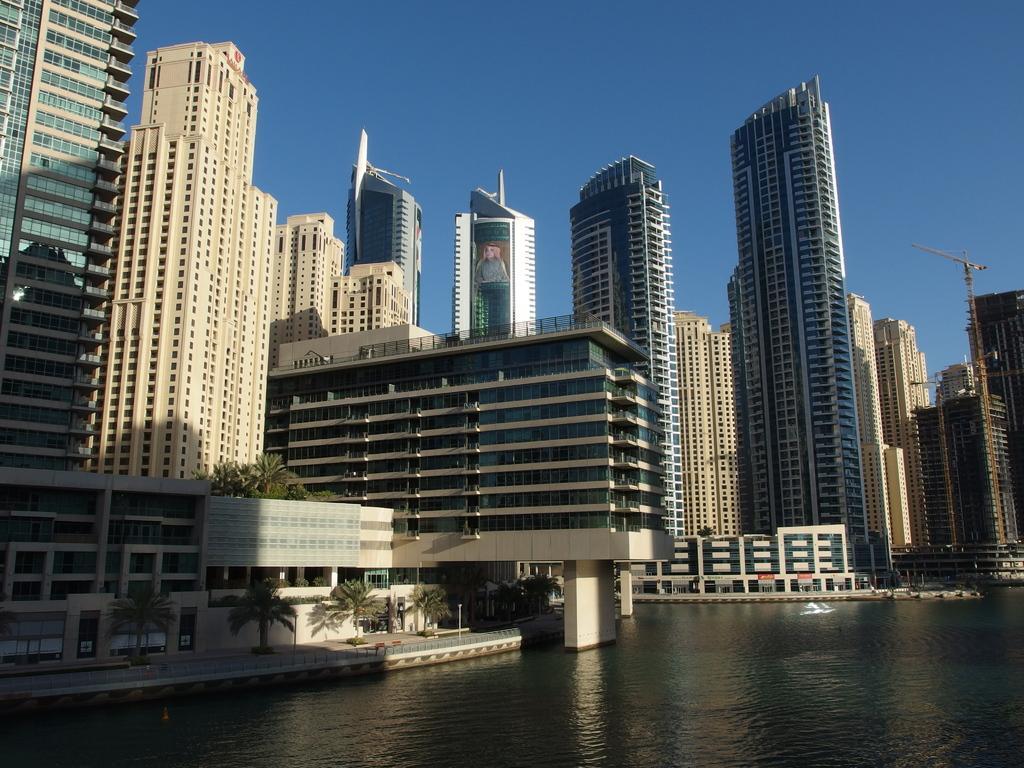Could you give a brief overview of what you see in this image? As we can see in the image there are buildings, water, trees and sky. 